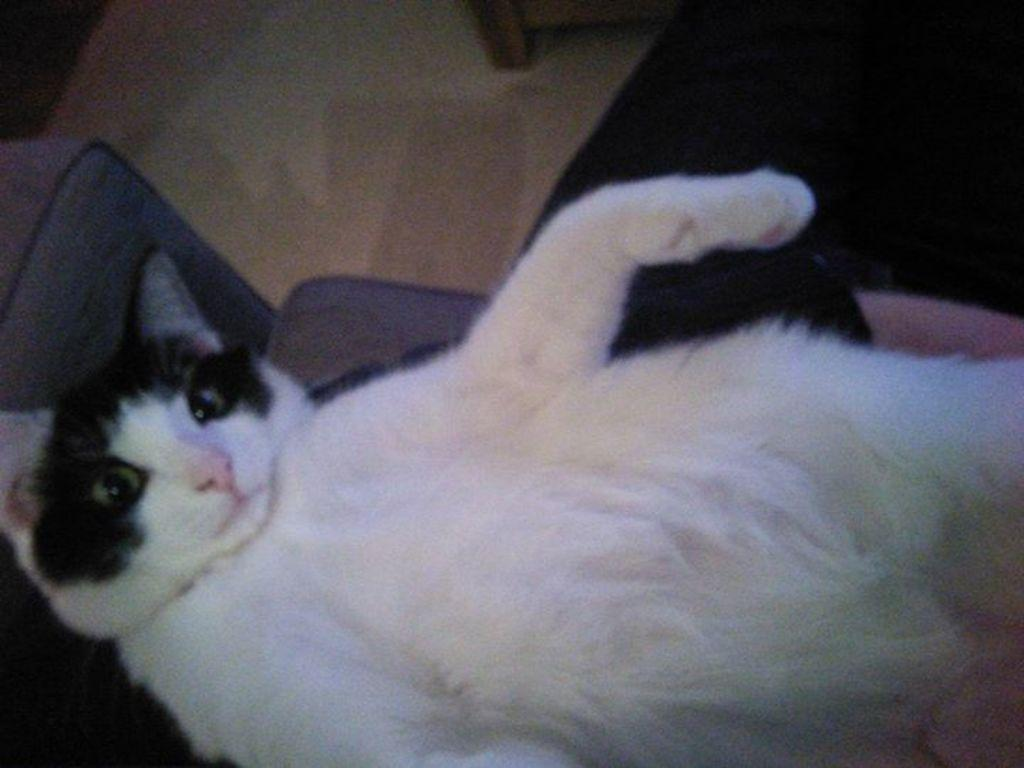What type of animal is in the picture? There is a white cat in the picture. Where is the cat located? The cat is lying on a sofa. What other furniture can be seen in the background of the picture? There is a chair in the background of the picture. What is at the bottom of the picture? There is a mat at the bottom of the picture. What type of fruit is the cat holding in its paw in the picture? There is no fruit, such as a quince, present in the picture, and the cat is not holding anything in its paw. 